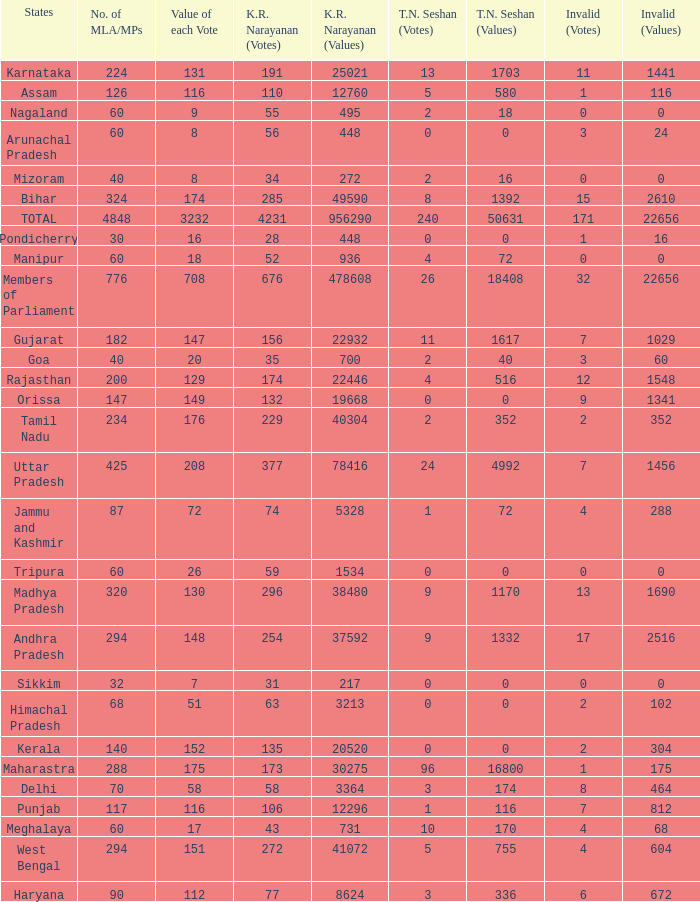Name the most kr votes for value of each vote for 208 377.0. 